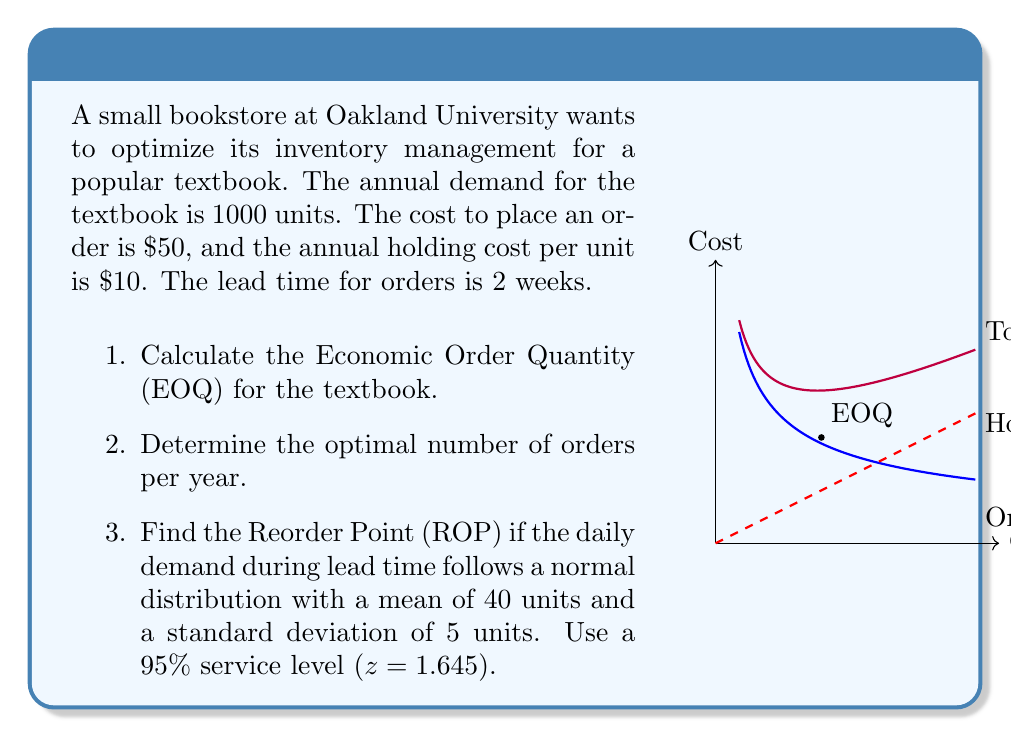Teach me how to tackle this problem. Let's solve this problem step by step:

1. Economic Order Quantity (EOQ):
   The EOQ formula is: $$ EOQ = \sqrt{\frac{2DS}{H}} $$
   Where:
   D = Annual demand = 1000 units
   S = Ordering cost = $50
   H = Annual holding cost per unit = $10

   Plugging in the values:
   $$ EOQ = \sqrt{\frac{2 \times 1000 \times 50}{10}} = \sqrt{10000} = 100 \text{ units} $$

2. Optimal number of orders per year:
   This can be calculated by dividing the annual demand by the EOQ:
   $$ \text{Number of orders} = \frac{D}{EOQ} = \frac{1000}{100} = 10 \text{ orders per year} $$

3. Reorder Point (ROP):
   The formula for ROP with safety stock is:
   $$ ROP = (\text{Average daily demand} \times \text{Lead time in days}) + \text{Safety Stock} $$

   Average daily demand during lead time = 40 units
   Lead time = 2 weeks = 14 days
   
   Safety Stock = $z \times \sigma \times \sqrt{\text{Lead time}}$
   Where z = 1.645 for 95% service level, and σ = 5 (standard deviation of daily demand)

   $$ \text{Safety Stock} = 1.645 \times 5 \times \sqrt{14} = 30.76 \text{ units} $$

   Now, we can calculate the ROP:
   $$ ROP = (40 \times 14) + 30.76 = 590.76 \approx 591 \text{ units} $$

The graph in the question illustrates the relationship between order quantity, holding costs, and ordering costs, with the EOQ at the point where total cost is minimized.
Answer: 1. EOQ = 100 units
2. 10 orders per year
3. ROP = 591 units 